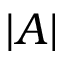<formula> <loc_0><loc_0><loc_500><loc_500>| A |</formula> 